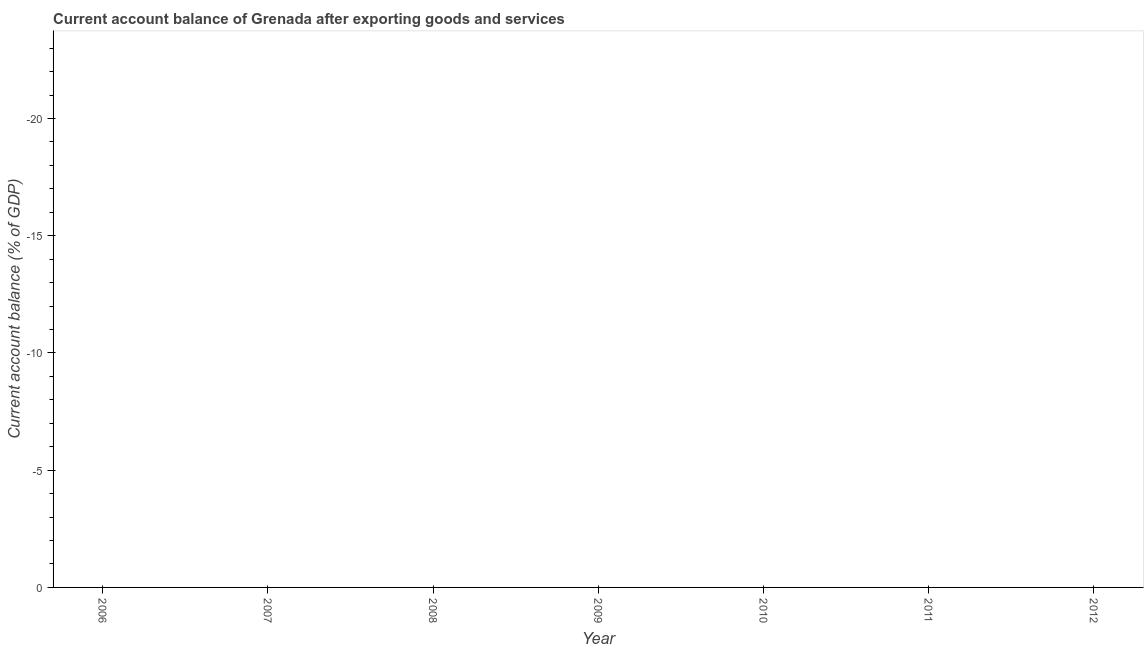What is the current account balance in 2008?
Ensure brevity in your answer.  0. What is the sum of the current account balance?
Provide a short and direct response. 0. What is the average current account balance per year?
Your answer should be compact. 0. In how many years, is the current account balance greater than the average current account balance taken over all years?
Offer a terse response. 0. What is the difference between two consecutive major ticks on the Y-axis?
Provide a short and direct response. 5. Does the graph contain grids?
Give a very brief answer. No. What is the title of the graph?
Provide a short and direct response. Current account balance of Grenada after exporting goods and services. What is the label or title of the Y-axis?
Provide a succinct answer. Current account balance (% of GDP). What is the Current account balance (% of GDP) in 2007?
Ensure brevity in your answer.  0. What is the Current account balance (% of GDP) in 2010?
Make the answer very short. 0. What is the Current account balance (% of GDP) in 2011?
Keep it short and to the point. 0. What is the Current account balance (% of GDP) in 2012?
Make the answer very short. 0. 